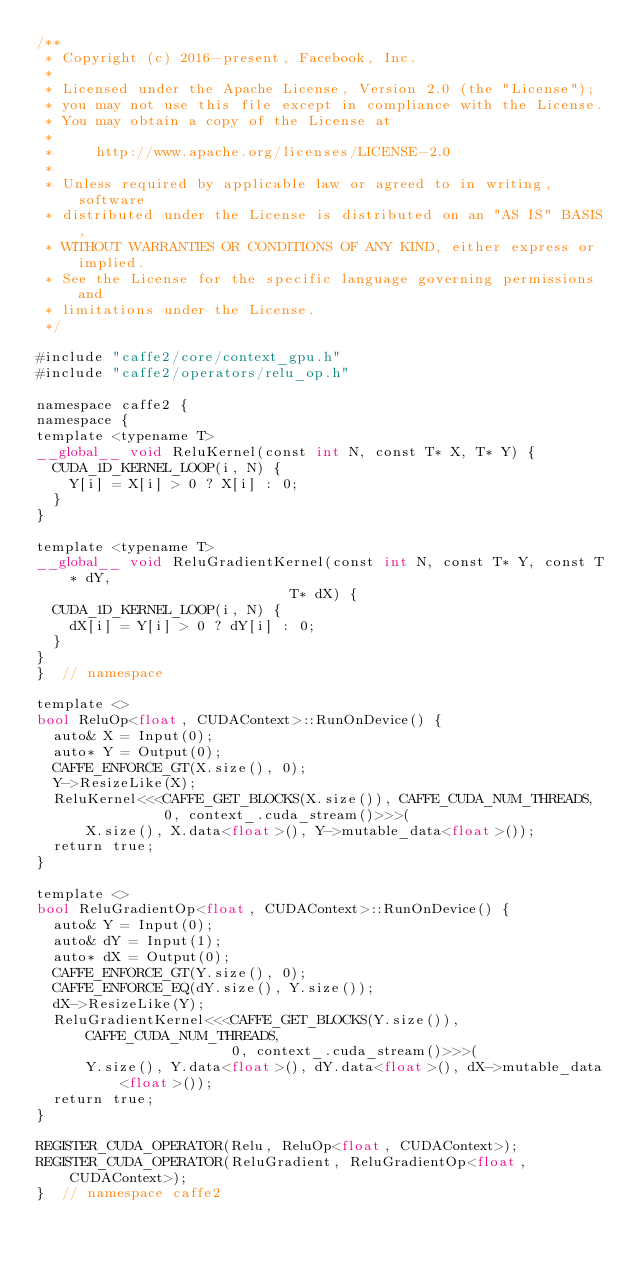Convert code to text. <code><loc_0><loc_0><loc_500><loc_500><_Cuda_>/**
 * Copyright (c) 2016-present, Facebook, Inc.
 *
 * Licensed under the Apache License, Version 2.0 (the "License");
 * you may not use this file except in compliance with the License.
 * You may obtain a copy of the License at
 *
 *     http://www.apache.org/licenses/LICENSE-2.0
 *
 * Unless required by applicable law or agreed to in writing, software
 * distributed under the License is distributed on an "AS IS" BASIS,
 * WITHOUT WARRANTIES OR CONDITIONS OF ANY KIND, either express or implied.
 * See the License for the specific language governing permissions and
 * limitations under the License.
 */

#include "caffe2/core/context_gpu.h"
#include "caffe2/operators/relu_op.h"

namespace caffe2 {
namespace {
template <typename T>
__global__ void ReluKernel(const int N, const T* X, T* Y) {
  CUDA_1D_KERNEL_LOOP(i, N) {
    Y[i] = X[i] > 0 ? X[i] : 0;
  }
}

template <typename T>
__global__ void ReluGradientKernel(const int N, const T* Y, const T* dY,
                              T* dX) {
  CUDA_1D_KERNEL_LOOP(i, N) {
    dX[i] = Y[i] > 0 ? dY[i] : 0;
  }
}
}  // namespace

template <>
bool ReluOp<float, CUDAContext>::RunOnDevice() {
  auto& X = Input(0);
  auto* Y = Output(0);
  CAFFE_ENFORCE_GT(X.size(), 0);
  Y->ResizeLike(X);
  ReluKernel<<<CAFFE_GET_BLOCKS(X.size()), CAFFE_CUDA_NUM_THREADS,
               0, context_.cuda_stream()>>>(
      X.size(), X.data<float>(), Y->mutable_data<float>());
  return true;
}

template <>
bool ReluGradientOp<float, CUDAContext>::RunOnDevice() {
  auto& Y = Input(0);
  auto& dY = Input(1);
  auto* dX = Output(0);
  CAFFE_ENFORCE_GT(Y.size(), 0);
  CAFFE_ENFORCE_EQ(dY.size(), Y.size());
  dX->ResizeLike(Y);
  ReluGradientKernel<<<CAFFE_GET_BLOCKS(Y.size()), CAFFE_CUDA_NUM_THREADS,
                       0, context_.cuda_stream()>>>(
      Y.size(), Y.data<float>(), dY.data<float>(), dX->mutable_data<float>());
  return true;
}

REGISTER_CUDA_OPERATOR(Relu, ReluOp<float, CUDAContext>);
REGISTER_CUDA_OPERATOR(ReluGradient, ReluGradientOp<float, CUDAContext>);
}  // namespace caffe2
</code> 